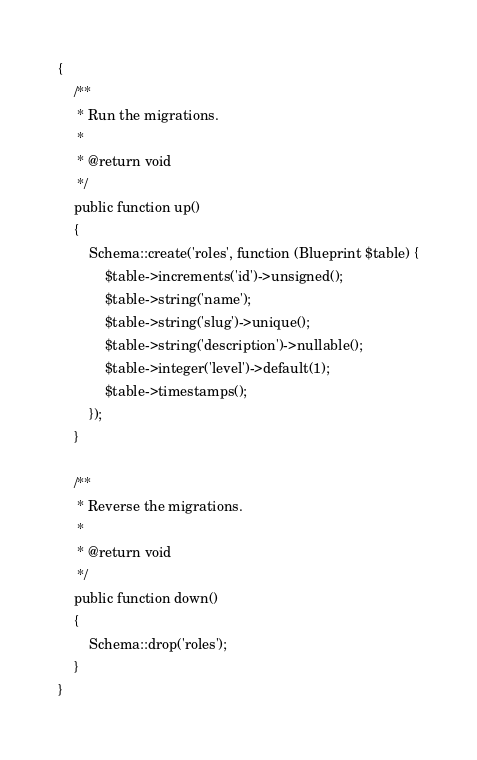<code> <loc_0><loc_0><loc_500><loc_500><_PHP_>{
    /**
     * Run the migrations.
     *
     * @return void
     */
    public function up()
    {
        Schema::create('roles', function (Blueprint $table) {
            $table->increments('id')->unsigned();
            $table->string('name');
            $table->string('slug')->unique();
            $table->string('description')->nullable();
            $table->integer('level')->default(1);
            $table->timestamps();
        });
    }

    /**
     * Reverse the migrations.
     *
     * @return void
     */
    public function down()
    {
        Schema::drop('roles');
    }
}
</code> 